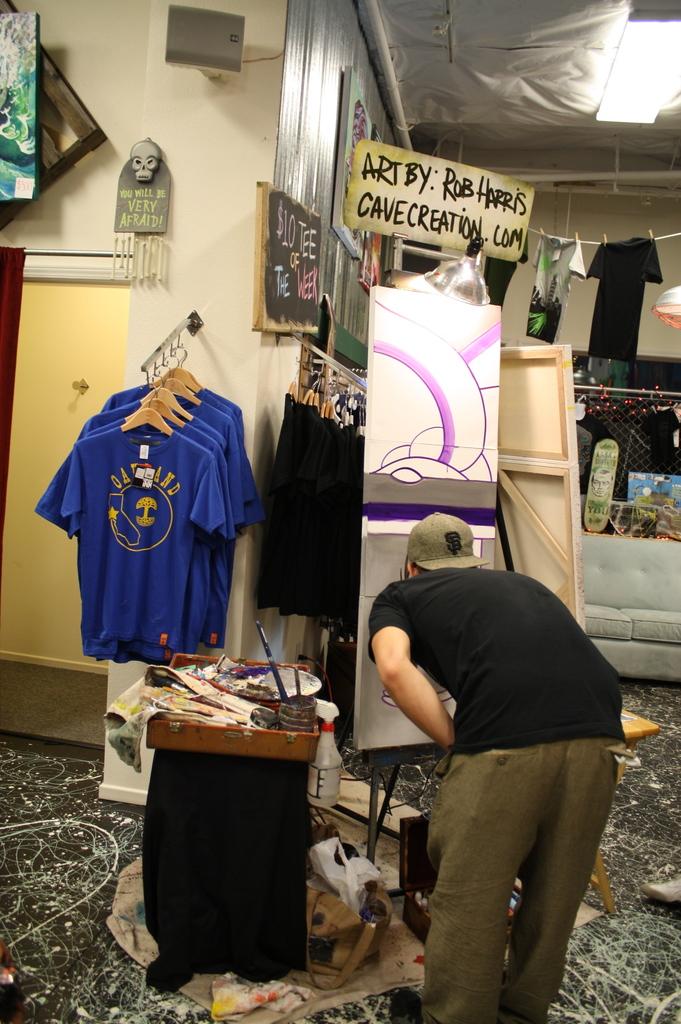Who is the art by?
Your answer should be very brief. Rob harris. What is the website for this artist?
Your answer should be very brief. Cavecreation.com. 